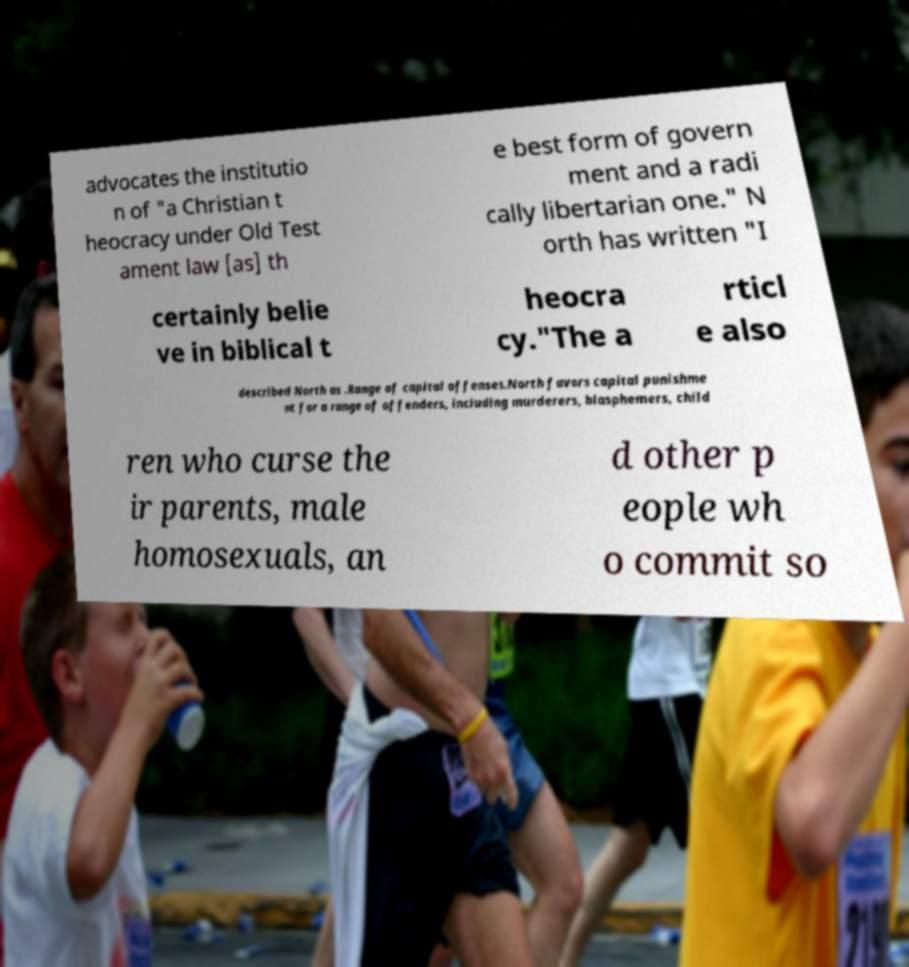Could you assist in decoding the text presented in this image and type it out clearly? advocates the institutio n of "a Christian t heocracy under Old Test ament law [as] th e best form of govern ment and a radi cally libertarian one." N orth has written "I certainly belie ve in biblical t heocra cy."The a rticl e also described North as .Range of capital offenses.North favors capital punishme nt for a range of offenders, including murderers, blasphemers, child ren who curse the ir parents, male homosexuals, an d other p eople wh o commit so 